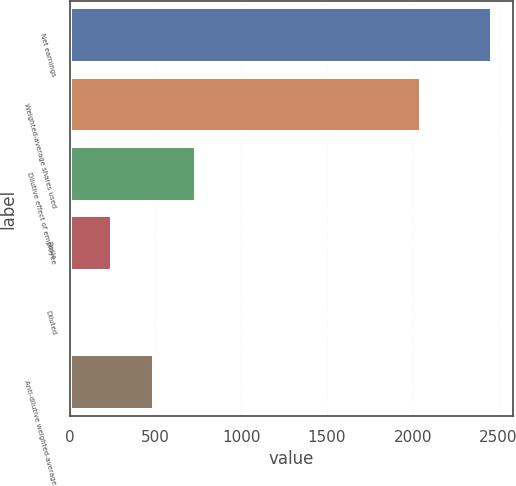<chart> <loc_0><loc_0><loc_500><loc_500><bar_chart><fcel>Net earnings<fcel>Weighted-average shares used<fcel>Dilutive effect of employee<fcel>Basic<fcel>Diluted<fcel>Anti-dilutive weighted-average<nl><fcel>2461<fcel>2049.97<fcel>739.25<fcel>247.31<fcel>1.34<fcel>493.28<nl></chart> 